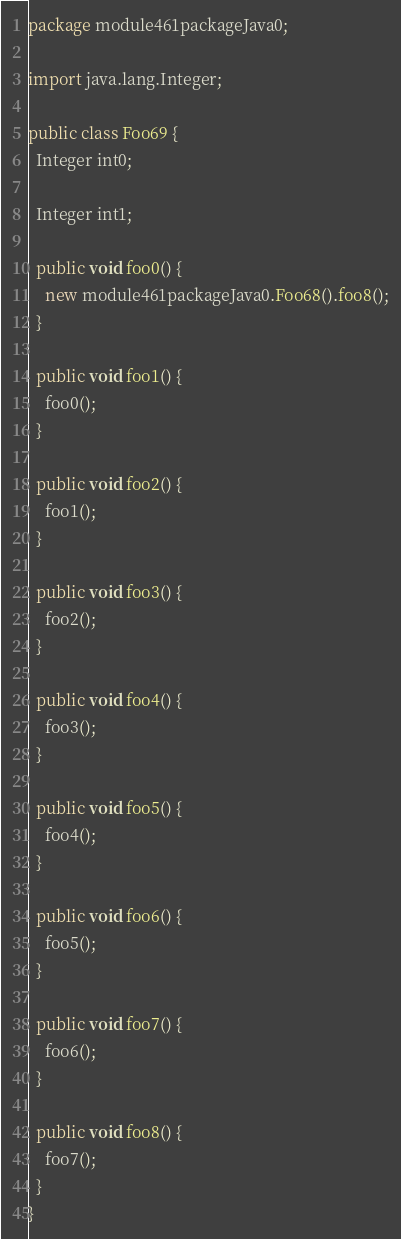Convert code to text. <code><loc_0><loc_0><loc_500><loc_500><_Java_>package module461packageJava0;

import java.lang.Integer;

public class Foo69 {
  Integer int0;

  Integer int1;

  public void foo0() {
    new module461packageJava0.Foo68().foo8();
  }

  public void foo1() {
    foo0();
  }

  public void foo2() {
    foo1();
  }

  public void foo3() {
    foo2();
  }

  public void foo4() {
    foo3();
  }

  public void foo5() {
    foo4();
  }

  public void foo6() {
    foo5();
  }

  public void foo7() {
    foo6();
  }

  public void foo8() {
    foo7();
  }
}
</code> 